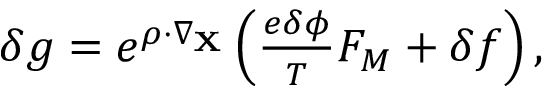Convert formula to latex. <formula><loc_0><loc_0><loc_500><loc_500>\begin{array} { r } { \delta g = e ^ { \rho \cdot \nabla _ { X } } \left ( \frac { e \delta \phi } { T } F _ { M } + \delta f \right ) , } \end{array}</formula> 